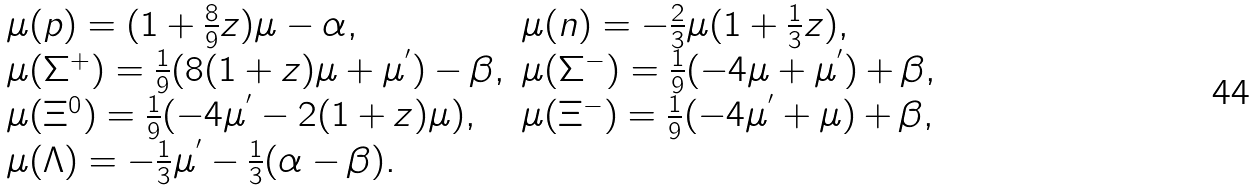<formula> <loc_0><loc_0><loc_500><loc_500>\begin{array} { l l } \mu ( p ) = ( 1 + \frac { 8 } { 9 } z ) \mu - \alpha , & \mu ( n ) = - \frac { 2 } { 3 } \mu ( 1 + \frac { 1 } { 3 } z ) , \\ \mu ( \Sigma ^ { + } ) = \frac { 1 } { 9 } ( 8 ( 1 + z ) \mu + \mu ^ { ^ { \prime } } ) - \beta , & \mu ( \Sigma ^ { - } ) = \frac { 1 } { 9 } ( - 4 \mu + \mu ^ { ^ { \prime } } ) + \beta , \\ \mu ( \Xi ^ { 0 } ) = \frac { 1 } { 9 } ( - 4 \mu ^ { ^ { \prime } } - 2 ( 1 + z ) \mu ) , & \mu ( \Xi ^ { - } ) = \frac { 1 } { 9 } ( - 4 \mu ^ { ^ { \prime } } + \mu ) + \beta , \\ \mu ( \Lambda ) = - \frac { 1 } { 3 } \mu ^ { ^ { \prime } } - \frac { 1 } { 3 } ( \alpha - \beta ) . \end{array}</formula> 